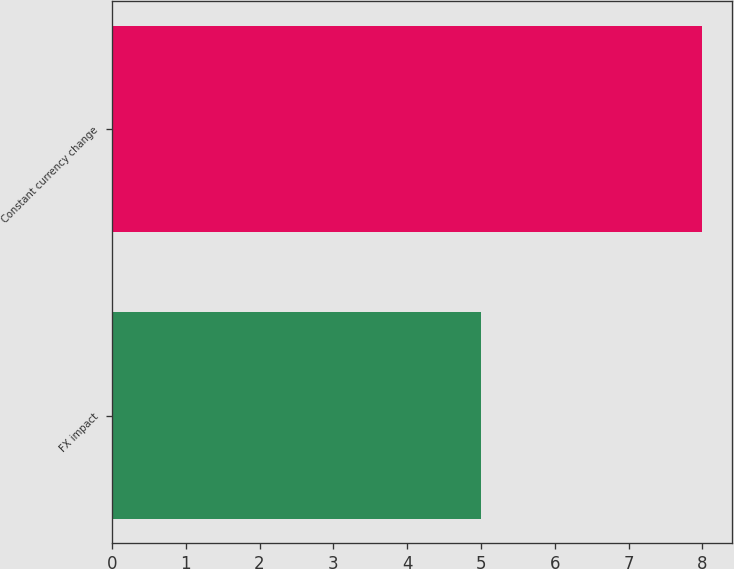<chart> <loc_0><loc_0><loc_500><loc_500><bar_chart><fcel>FX impact<fcel>Constant currency change<nl><fcel>5<fcel>8<nl></chart> 